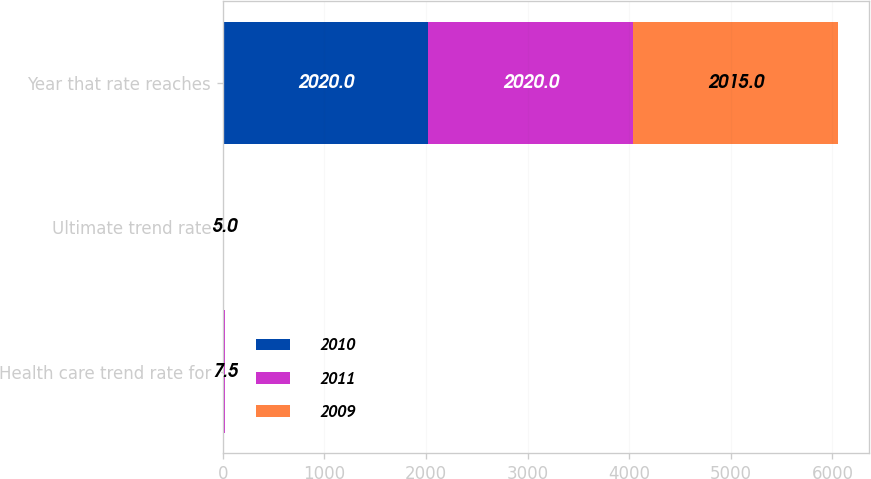Convert chart. <chart><loc_0><loc_0><loc_500><loc_500><stacked_bar_chart><ecel><fcel>Health care trend rate for<fcel>Ultimate trend rate<fcel>Year that rate reaches<nl><fcel>2010<fcel>8.5<fcel>5<fcel>2020<nl><fcel>2011<fcel>9<fcel>5<fcel>2020<nl><fcel>2009<fcel>7.5<fcel>5<fcel>2015<nl></chart> 